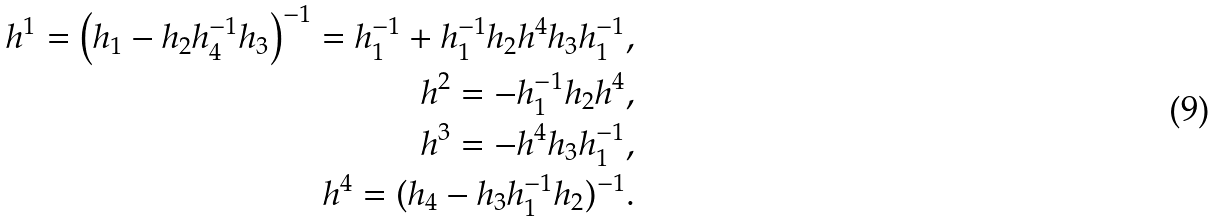<formula> <loc_0><loc_0><loc_500><loc_500>h ^ { 1 } = \left ( h _ { 1 } - h _ { 2 } h ^ { - 1 } _ { 4 } h _ { 3 } \right ) ^ { - 1 } = h _ { 1 } ^ { - 1 } + h _ { 1 } ^ { - 1 } h _ { 2 } h ^ { 4 } h _ { 3 } h _ { 1 } ^ { - 1 } , \\ h ^ { 2 } = - h ^ { - 1 } _ { 1 } h _ { 2 } h ^ { 4 } , \\ h ^ { 3 } = - h ^ { 4 } h _ { 3 } h _ { 1 } ^ { - 1 } , \\ h ^ { 4 } = ( h _ { 4 } - h _ { 3 } h ^ { - 1 } _ { 1 } h _ { 2 } ) ^ { - 1 } .</formula> 